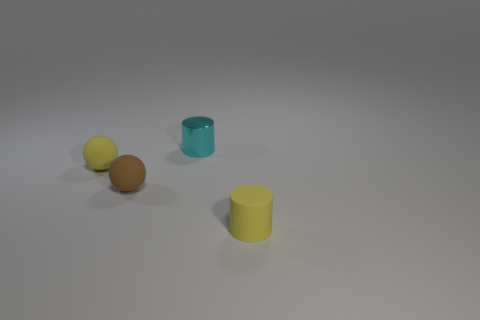There is a yellow object that is the same shape as the cyan object; what is it made of?
Make the answer very short. Rubber. Does the small brown object have the same shape as the metal object?
Provide a succinct answer. No. What number of cyan metal cylinders are on the left side of the cyan metal thing?
Your response must be concise. 0. What shape is the small yellow matte thing behind the tiny ball in front of the small yellow sphere?
Offer a terse response. Sphere. There is a tiny brown object that is made of the same material as the small yellow ball; what is its shape?
Offer a very short reply. Sphere. Is the size of the cylinder that is behind the matte cylinder the same as the yellow thing to the right of the tiny brown sphere?
Ensure brevity in your answer.  Yes. There is a yellow rubber object that is on the right side of the cyan metal cylinder; what is its shape?
Offer a very short reply. Cylinder. The shiny thing is what color?
Give a very brief answer. Cyan. Does the metallic cylinder have the same size as the cylinder on the right side of the tiny cyan metal object?
Offer a terse response. Yes. How many shiny things are tiny objects or yellow balls?
Your response must be concise. 1. 